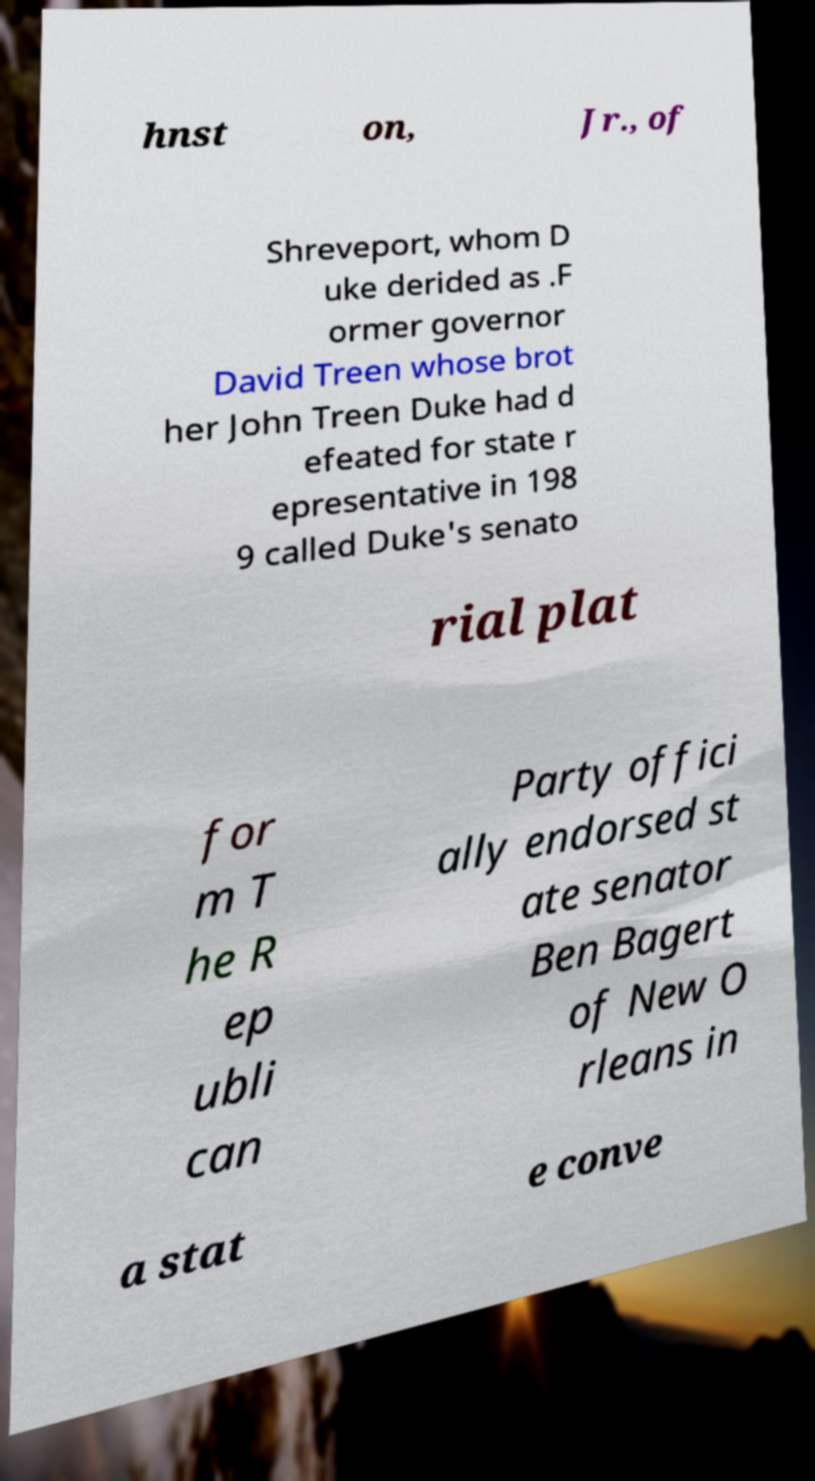For documentation purposes, I need the text within this image transcribed. Could you provide that? hnst on, Jr., of Shreveport, whom D uke derided as .F ormer governor David Treen whose brot her John Treen Duke had d efeated for state r epresentative in 198 9 called Duke's senato rial plat for m T he R ep ubli can Party offici ally endorsed st ate senator Ben Bagert of New O rleans in a stat e conve 